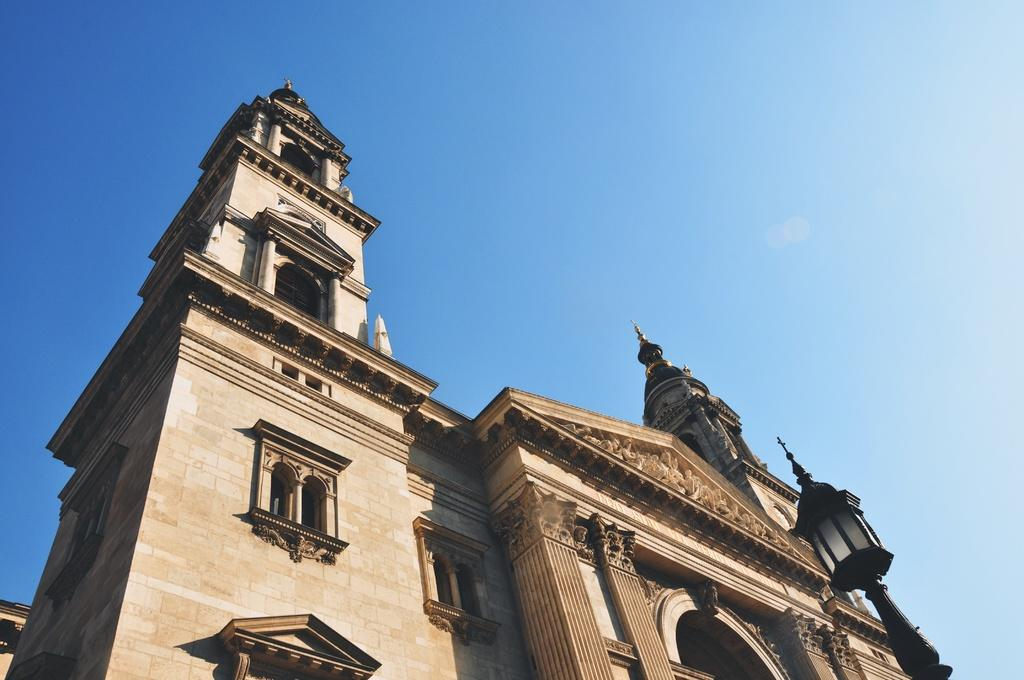What type of structure is featured in the image? There is a beautiful architecture in the image. How would you describe the details of the architecture? The architecture has perfect carvings and designs. From which angle was the image captured? The image is captured from the downside of the architecture. How many snails can be seen crawling on the cup in the image? There is no cup or snails present in the image; it features a beautiful architecture with perfect carvings and designs. 